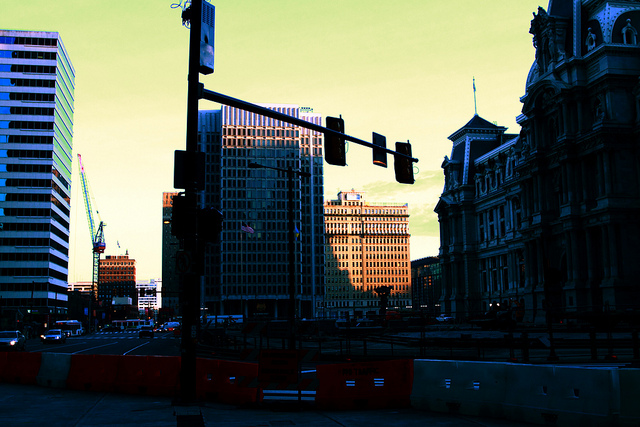What concerns could people have when navigating this downtown area during dusk? As the sun sets, navigating this downtown area could present several concerns. The primary issue is the decreasing light which could impair visibility, making it difficult to spot pedestrians, cyclists, or obstructions in the street. This risk is accentuated by the potentially insufficient street lighting and the shadows cast by the tall buildings surrounding the area. Moreover, the mix of fading natural light and the onset of city lights can create glares for drivers. Enhancing street illumination and clear signage becomes crucial to mitigate these risks. Reflective safety markers and well-lit pedestrian crossings could also improve safety during this transition time. 